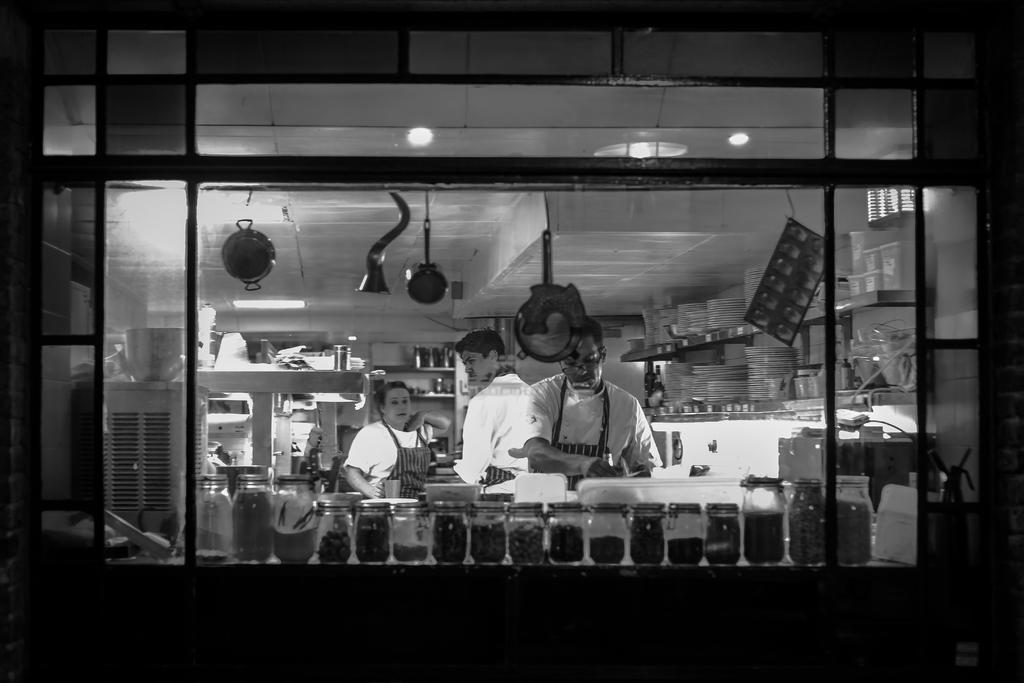Describe this image in one or two sentences. In this image there are few people in the kitchen room, there are few plates and objects arranged in the shelf's, there is a window, few glass jars on the table and some objects hanging from the roof. 